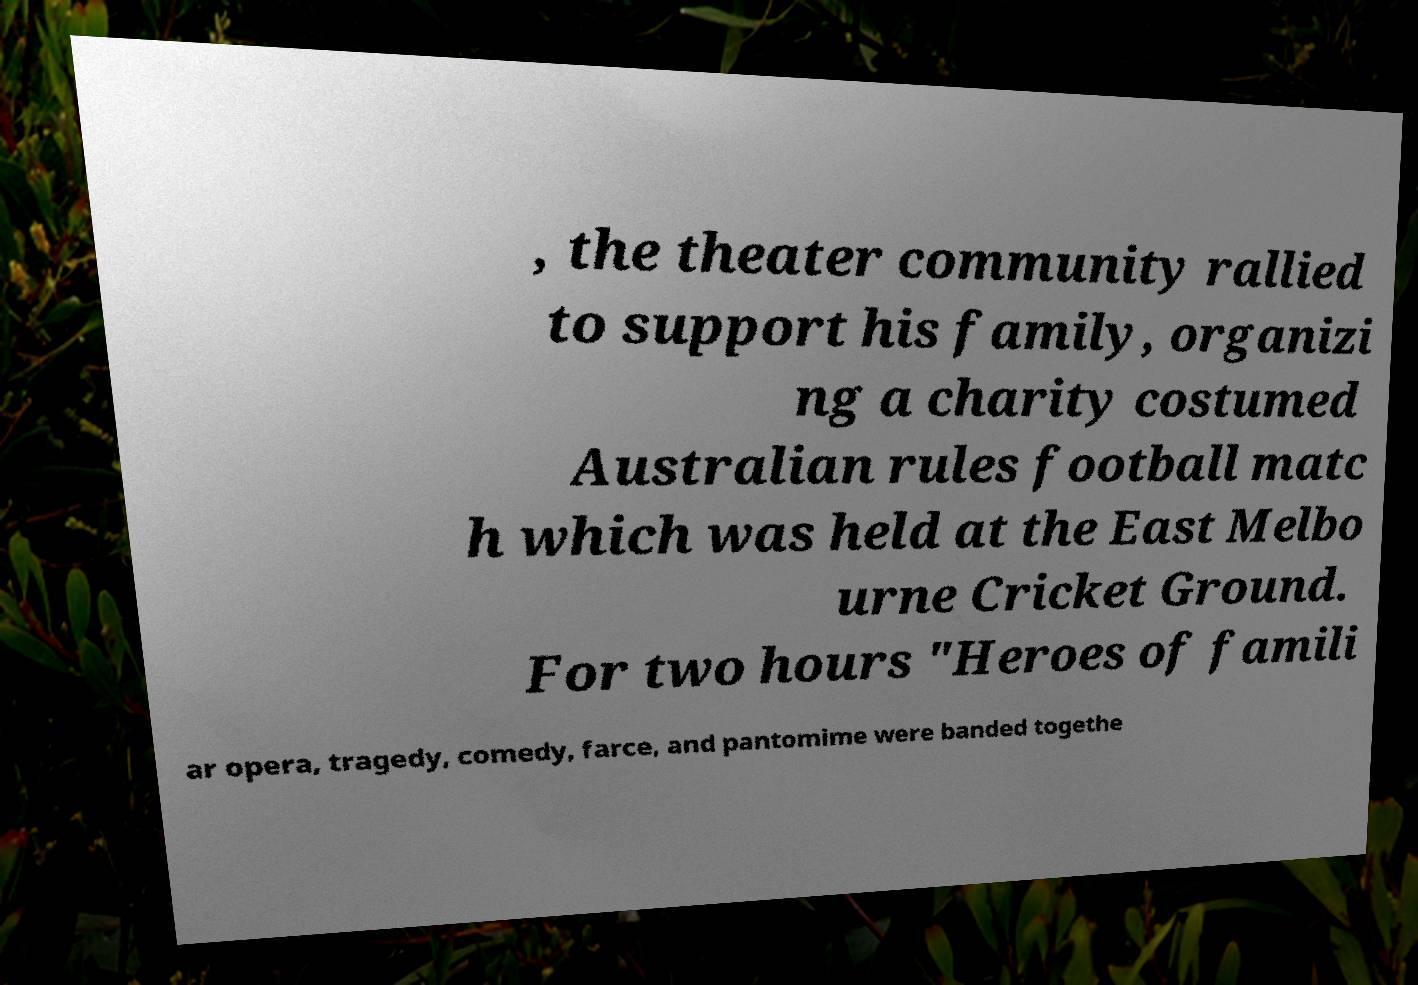Please identify and transcribe the text found in this image. , the theater community rallied to support his family, organizi ng a charity costumed Australian rules football matc h which was held at the East Melbo urne Cricket Ground. For two hours "Heroes of famili ar opera, tragedy, comedy, farce, and pantomime were banded togethe 